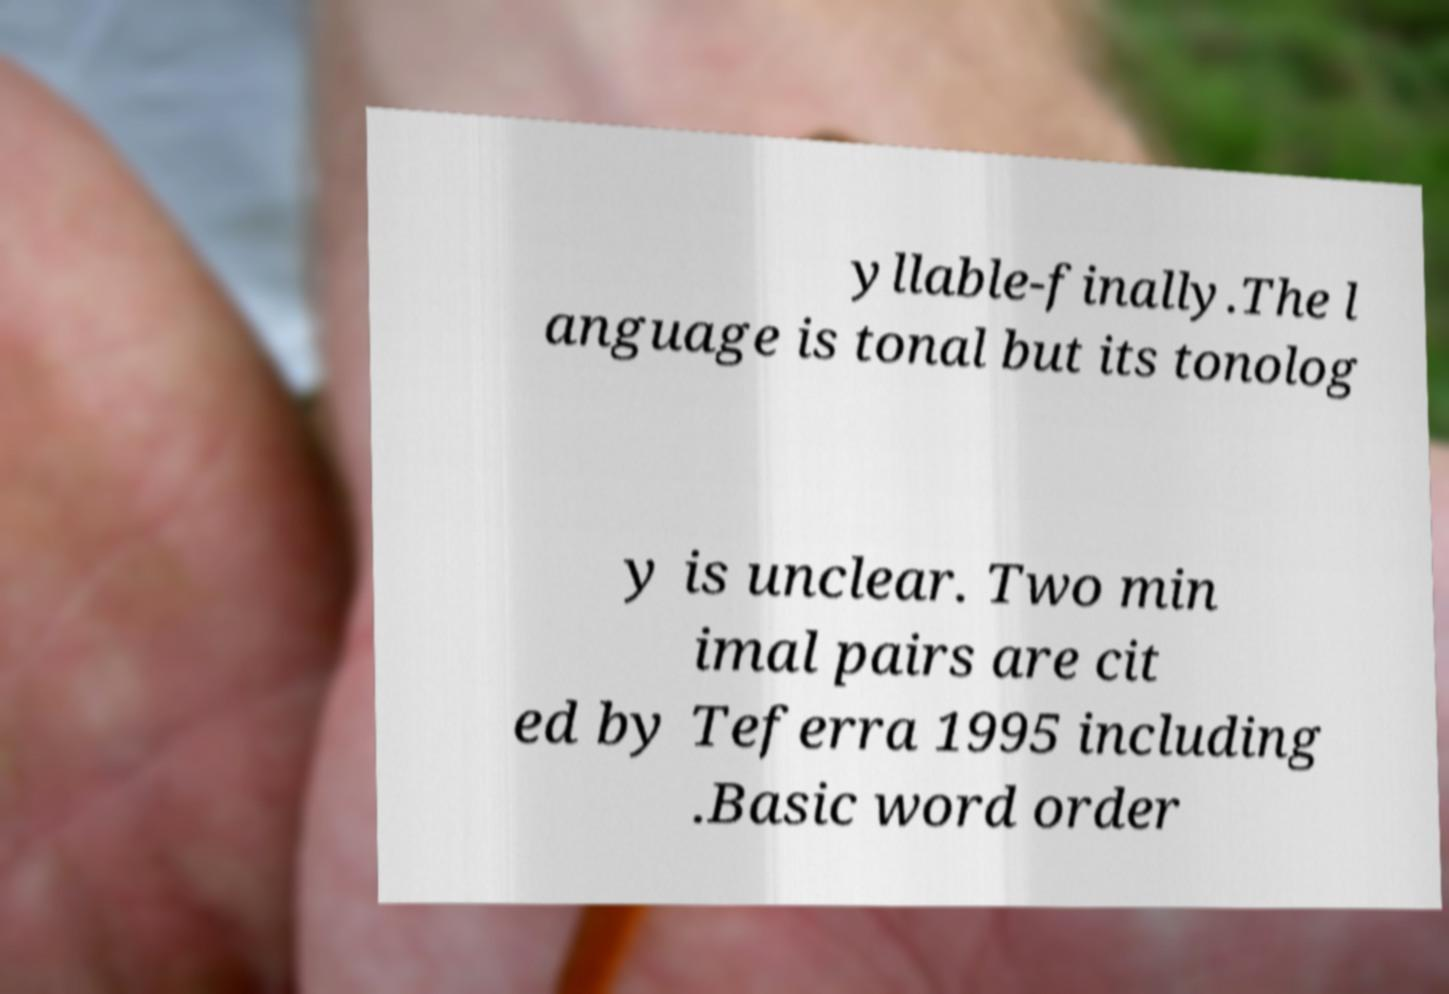Can you read and provide the text displayed in the image?This photo seems to have some interesting text. Can you extract and type it out for me? yllable-finally.The l anguage is tonal but its tonolog y is unclear. Two min imal pairs are cit ed by Teferra 1995 including .Basic word order 